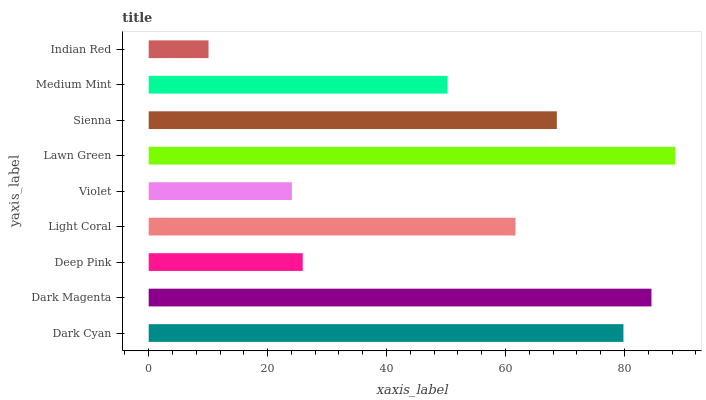Is Indian Red the minimum?
Answer yes or no. Yes. Is Lawn Green the maximum?
Answer yes or no. Yes. Is Dark Magenta the minimum?
Answer yes or no. No. Is Dark Magenta the maximum?
Answer yes or no. No. Is Dark Magenta greater than Dark Cyan?
Answer yes or no. Yes. Is Dark Cyan less than Dark Magenta?
Answer yes or no. Yes. Is Dark Cyan greater than Dark Magenta?
Answer yes or no. No. Is Dark Magenta less than Dark Cyan?
Answer yes or no. No. Is Light Coral the high median?
Answer yes or no. Yes. Is Light Coral the low median?
Answer yes or no. Yes. Is Indian Red the high median?
Answer yes or no. No. Is Violet the low median?
Answer yes or no. No. 